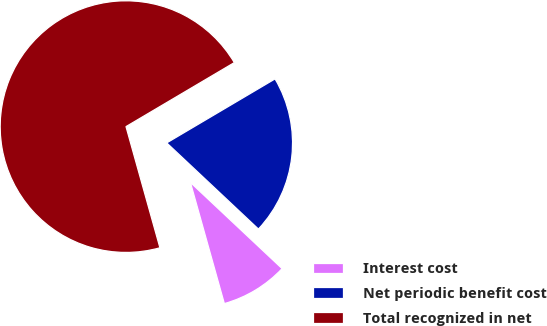<chart> <loc_0><loc_0><loc_500><loc_500><pie_chart><fcel>Interest cost<fcel>Net periodic benefit cost<fcel>Total recognized in net<nl><fcel>8.65%<fcel>20.5%<fcel>70.85%<nl></chart> 